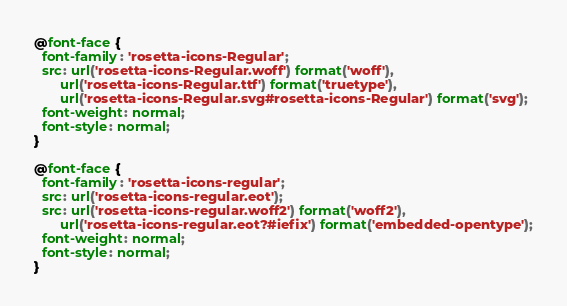Convert code to text. <code><loc_0><loc_0><loc_500><loc_500><_CSS_>@font-face {
  font-family: 'rosetta-icons-Regular';
  src: url('rosetta-icons-Regular.woff') format('woff'),
       url('rosetta-icons-Regular.ttf') format('truetype'),
       url('rosetta-icons-Regular.svg#rosetta-icons-Regular') format('svg');
  font-weight: normal;
  font-style: normal;
}

@font-face {
  font-family: 'rosetta-icons-regular';
  src: url('rosetta-icons-regular.eot');
  src: url('rosetta-icons-regular.woff2') format('woff2'),
       url('rosetta-icons-regular.eot?#iefix') format('embedded-opentype');
  font-weight: normal;
  font-style: normal;
}

</code> 